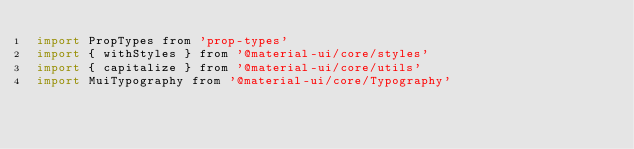<code> <loc_0><loc_0><loc_500><loc_500><_JavaScript_>import PropTypes from 'prop-types'
import { withStyles } from '@material-ui/core/styles'
import { capitalize } from '@material-ui/core/utils'
import MuiTypography from '@material-ui/core/Typography'
</code> 